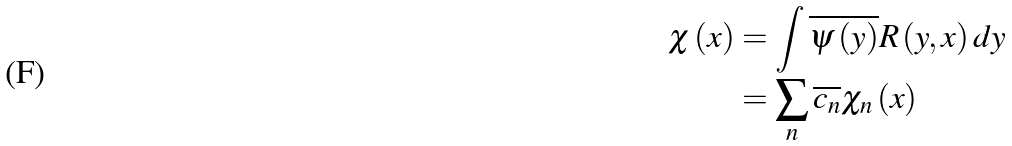Convert formula to latex. <formula><loc_0><loc_0><loc_500><loc_500>\chi \left ( x \right ) & = \int \overline { \psi \left ( y \right ) } R \left ( y , x \right ) d y \\ & = \sum _ { n } \overline { c _ { n } } \chi _ { n } \left ( x \right )</formula> 